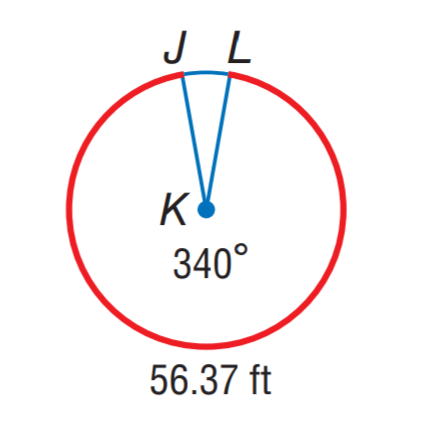Answer the mathemtical geometry problem and directly provide the correct option letter.
Question: Find the radius of \odot K. Round to the nearest hundredth.
Choices: A: 9.50 B: 19.00 C: 56.37 D: 59.69 B 